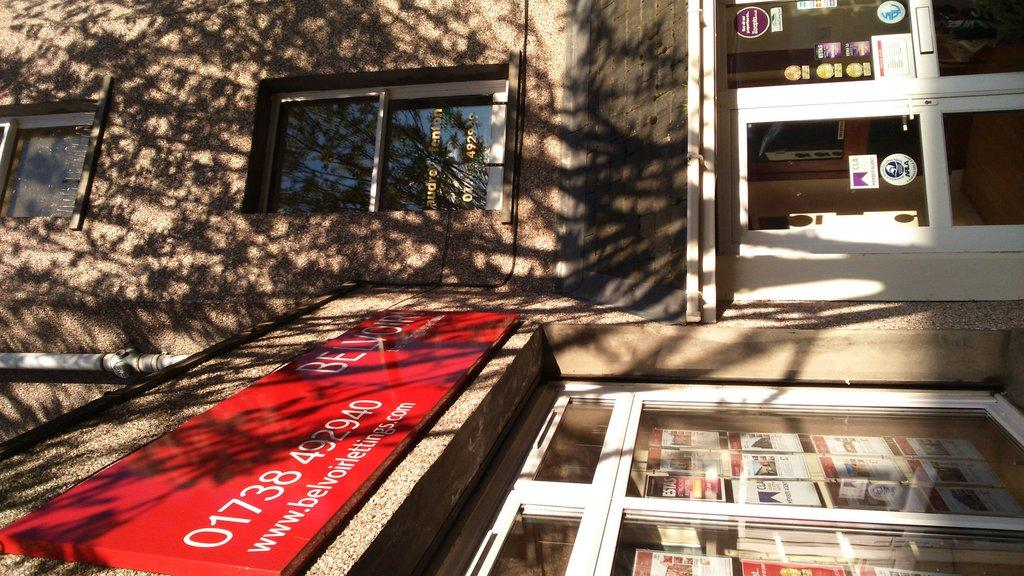What type of structure is present in the image? There is a building in the image. What are some features of the building? The building has windows and doors. Is there any additional information provided on the building? Yes, there is a sign board with text in the image. What type of toothbrush is hanging on the wall in the image? There is no toothbrush present in the image. Is the building made of steel in the image? The facts provided do not mention the material of the building, so we cannot determine if it is made of steel. 